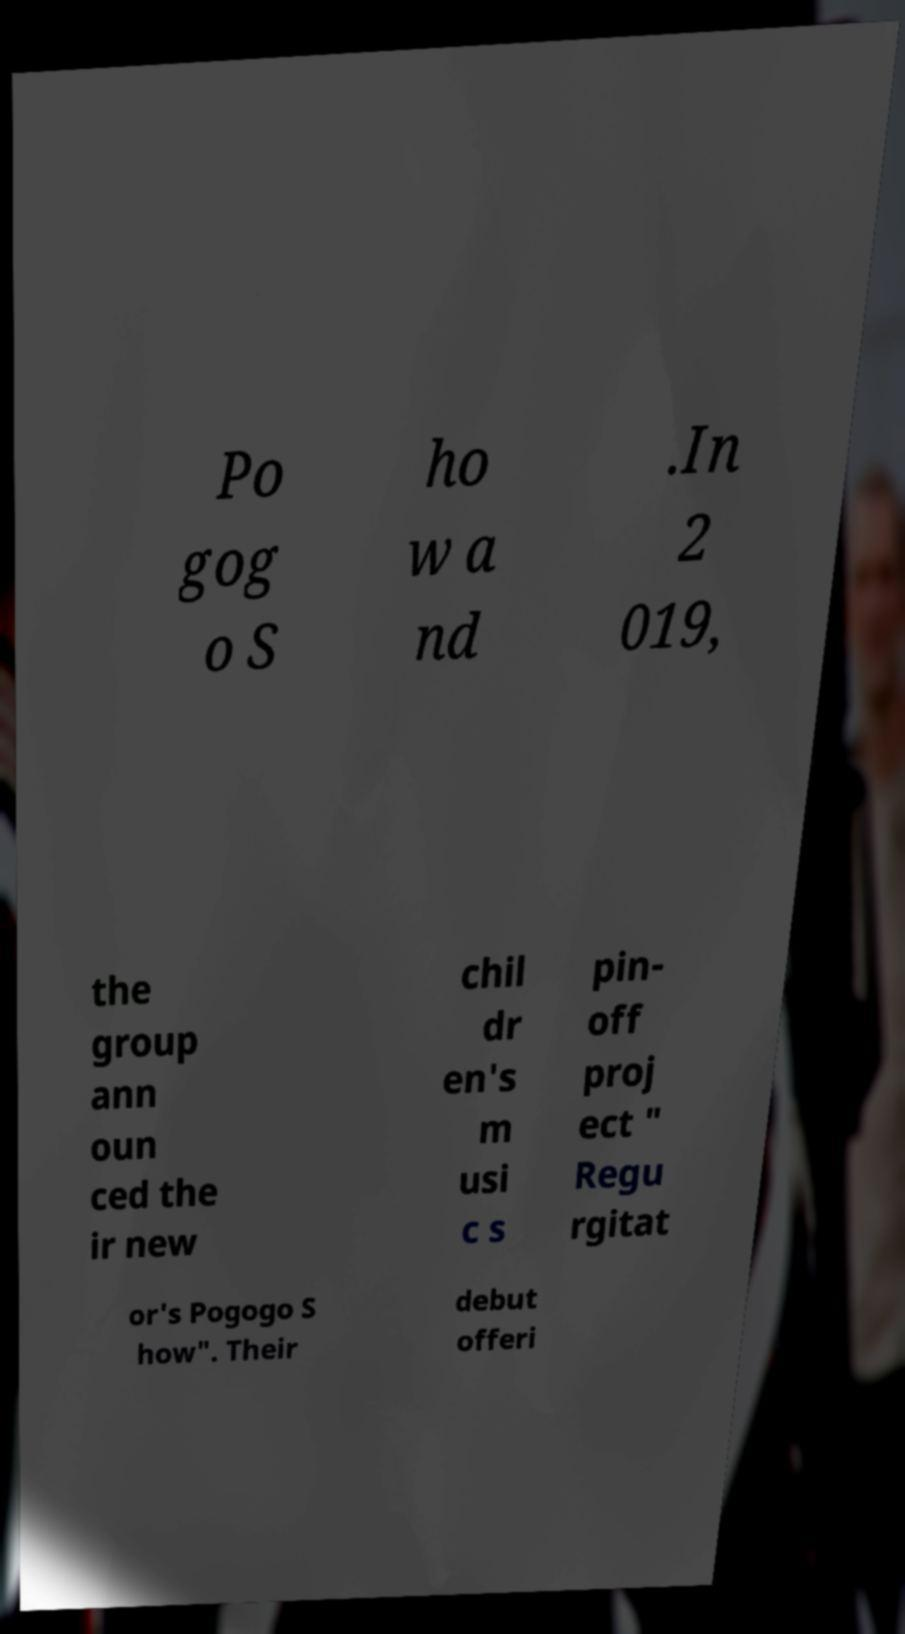Could you assist in decoding the text presented in this image and type it out clearly? Po gog o S ho w a nd .In 2 019, the group ann oun ced the ir new chil dr en's m usi c s pin- off proj ect " Regu rgitat or's Pogogo S how". Their debut offeri 